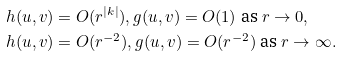Convert formula to latex. <formula><loc_0><loc_0><loc_500><loc_500>& h ( u , v ) = O ( r ^ { | k | } ) , g ( u , v ) = O ( 1 ) \text { as } r \rightarrow 0 , \\ & h ( u , v ) = O ( r ^ { - 2 } ) , g ( u , v ) = O ( r ^ { - 2 } ) \text { as } r \rightarrow \infty .</formula> 